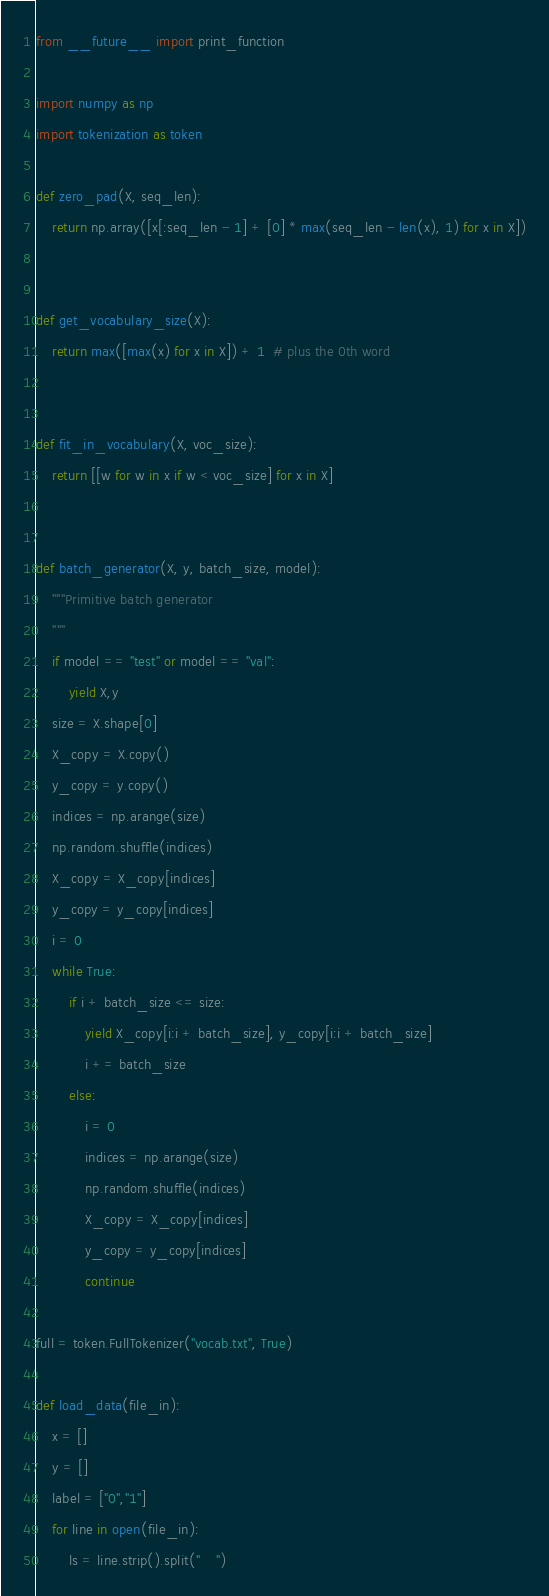Convert code to text. <code><loc_0><loc_0><loc_500><loc_500><_Python_>from __future__ import print_function

import numpy as np
import tokenization as token

def zero_pad(X, seq_len):
    return np.array([x[:seq_len - 1] + [0] * max(seq_len - len(x), 1) for x in X])


def get_vocabulary_size(X):
    return max([max(x) for x in X]) + 1  # plus the 0th word


def fit_in_vocabulary(X, voc_size):
    return [[w for w in x if w < voc_size] for x in X]


def batch_generator(X, y, batch_size, model):
    """Primitive batch generator 
    """
    if model == "test" or model == "val":
        yield X,y
    size = X.shape[0]
    X_copy = X.copy()
    y_copy = y.copy()
    indices = np.arange(size)
    np.random.shuffle(indices)
    X_copy = X_copy[indices]
    y_copy = y_copy[indices]
    i = 0
    while True:
        if i + batch_size <= size:
            yield X_copy[i:i + batch_size], y_copy[i:i + batch_size]
            i += batch_size
        else:
            i = 0
            indices = np.arange(size)
            np.random.shuffle(indices)
            X_copy = X_copy[indices]
            y_copy = y_copy[indices]
            continue

full = token.FullTokenizer("vocab.txt", True)

def load_data(file_in):
    x = []
    y = []
    label = ["0","1"]
    for line in open(file_in):
        ls = line.strip().split("	")</code> 